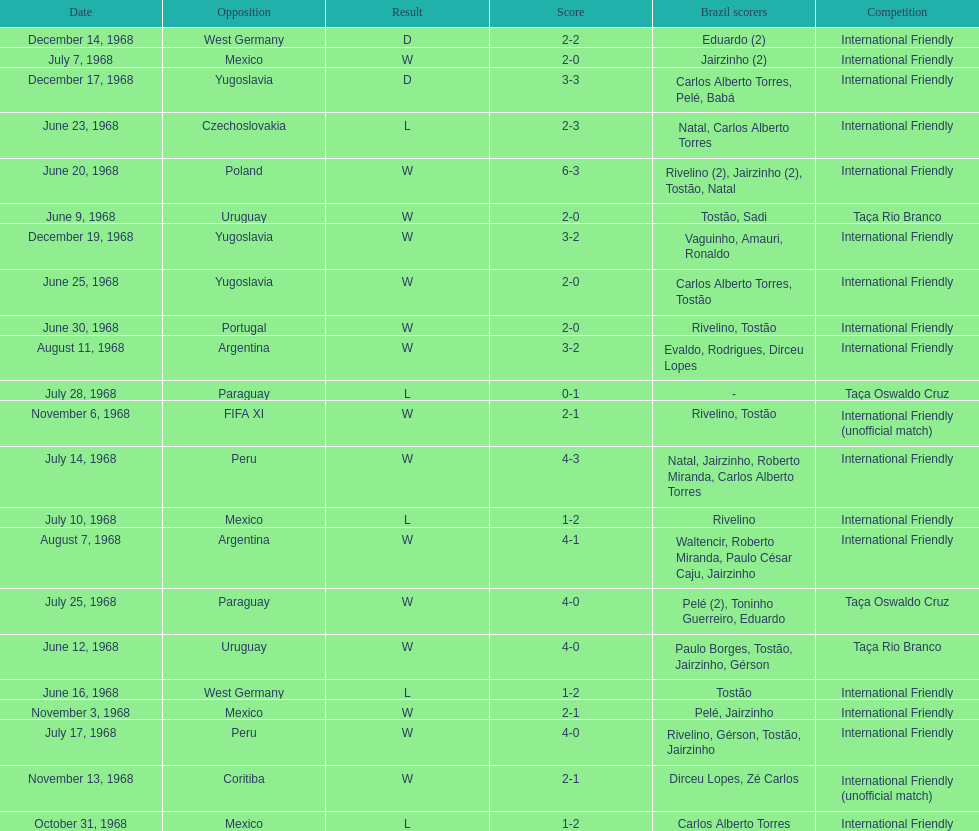Number of losses 5. 